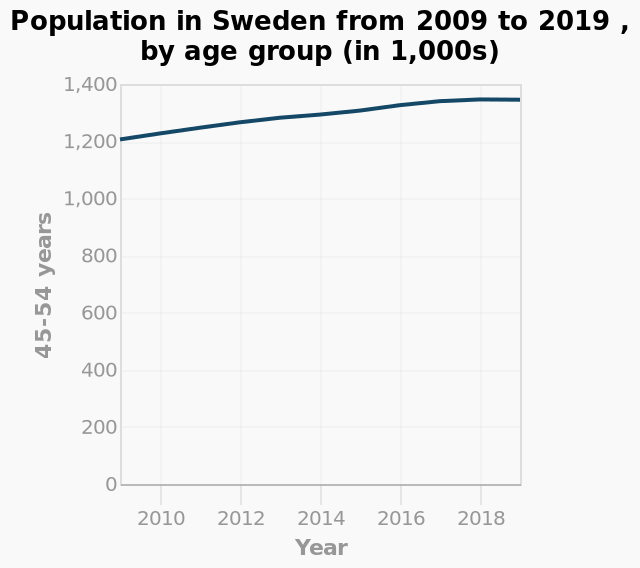<image>
What is the range of values on the y-axis of the line plot?  The y-axis of the line plot has a range from 0 to 1,400. What is the overall trend in population for the age group 45-54 years in Sweden from 2009 to 2019 according to the line plot? The line plot shows the fluctuation in population for the age group 45-54 years in Sweden from 2009 to 2019. Which age group is labeled on the y-axis of the line plot? The age group labeled on the y-axis of the line plot is 45-54 years. 